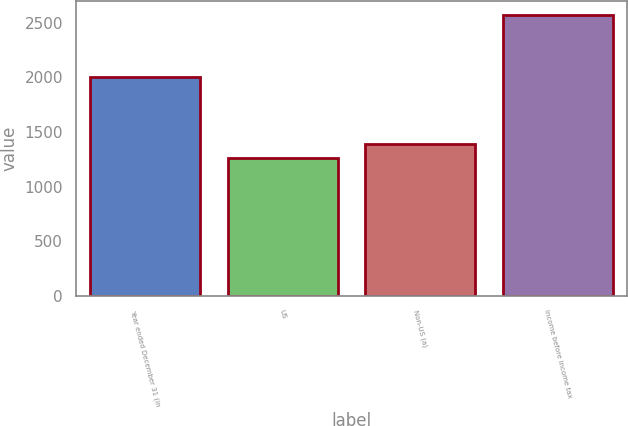<chart> <loc_0><loc_0><loc_500><loc_500><bar_chart><fcel>Year ended December 31 (in<fcel>US<fcel>Non-US (a)<fcel>Income before income tax<nl><fcel>2001<fcel>1258<fcel>1388.8<fcel>2566<nl></chart> 